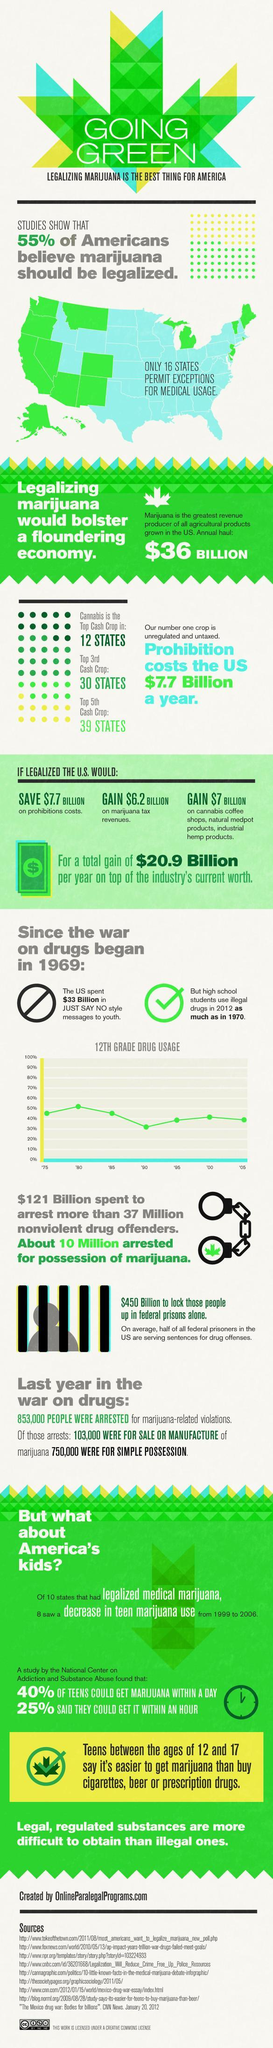What is the profit on marijuana tax revenues if it is legalized in the U.S.?
Answer the question with a short phrase. $6.2 BILLION What is the revenue earned from marijuana in the U.S. annual haul? $36 BILLION What is the money saved on prohibition costs if marijuana is legalized in the U.S.? $7.7 Billion What percentage of Americans do not believe that marijuana shoud be legalized? 45% 